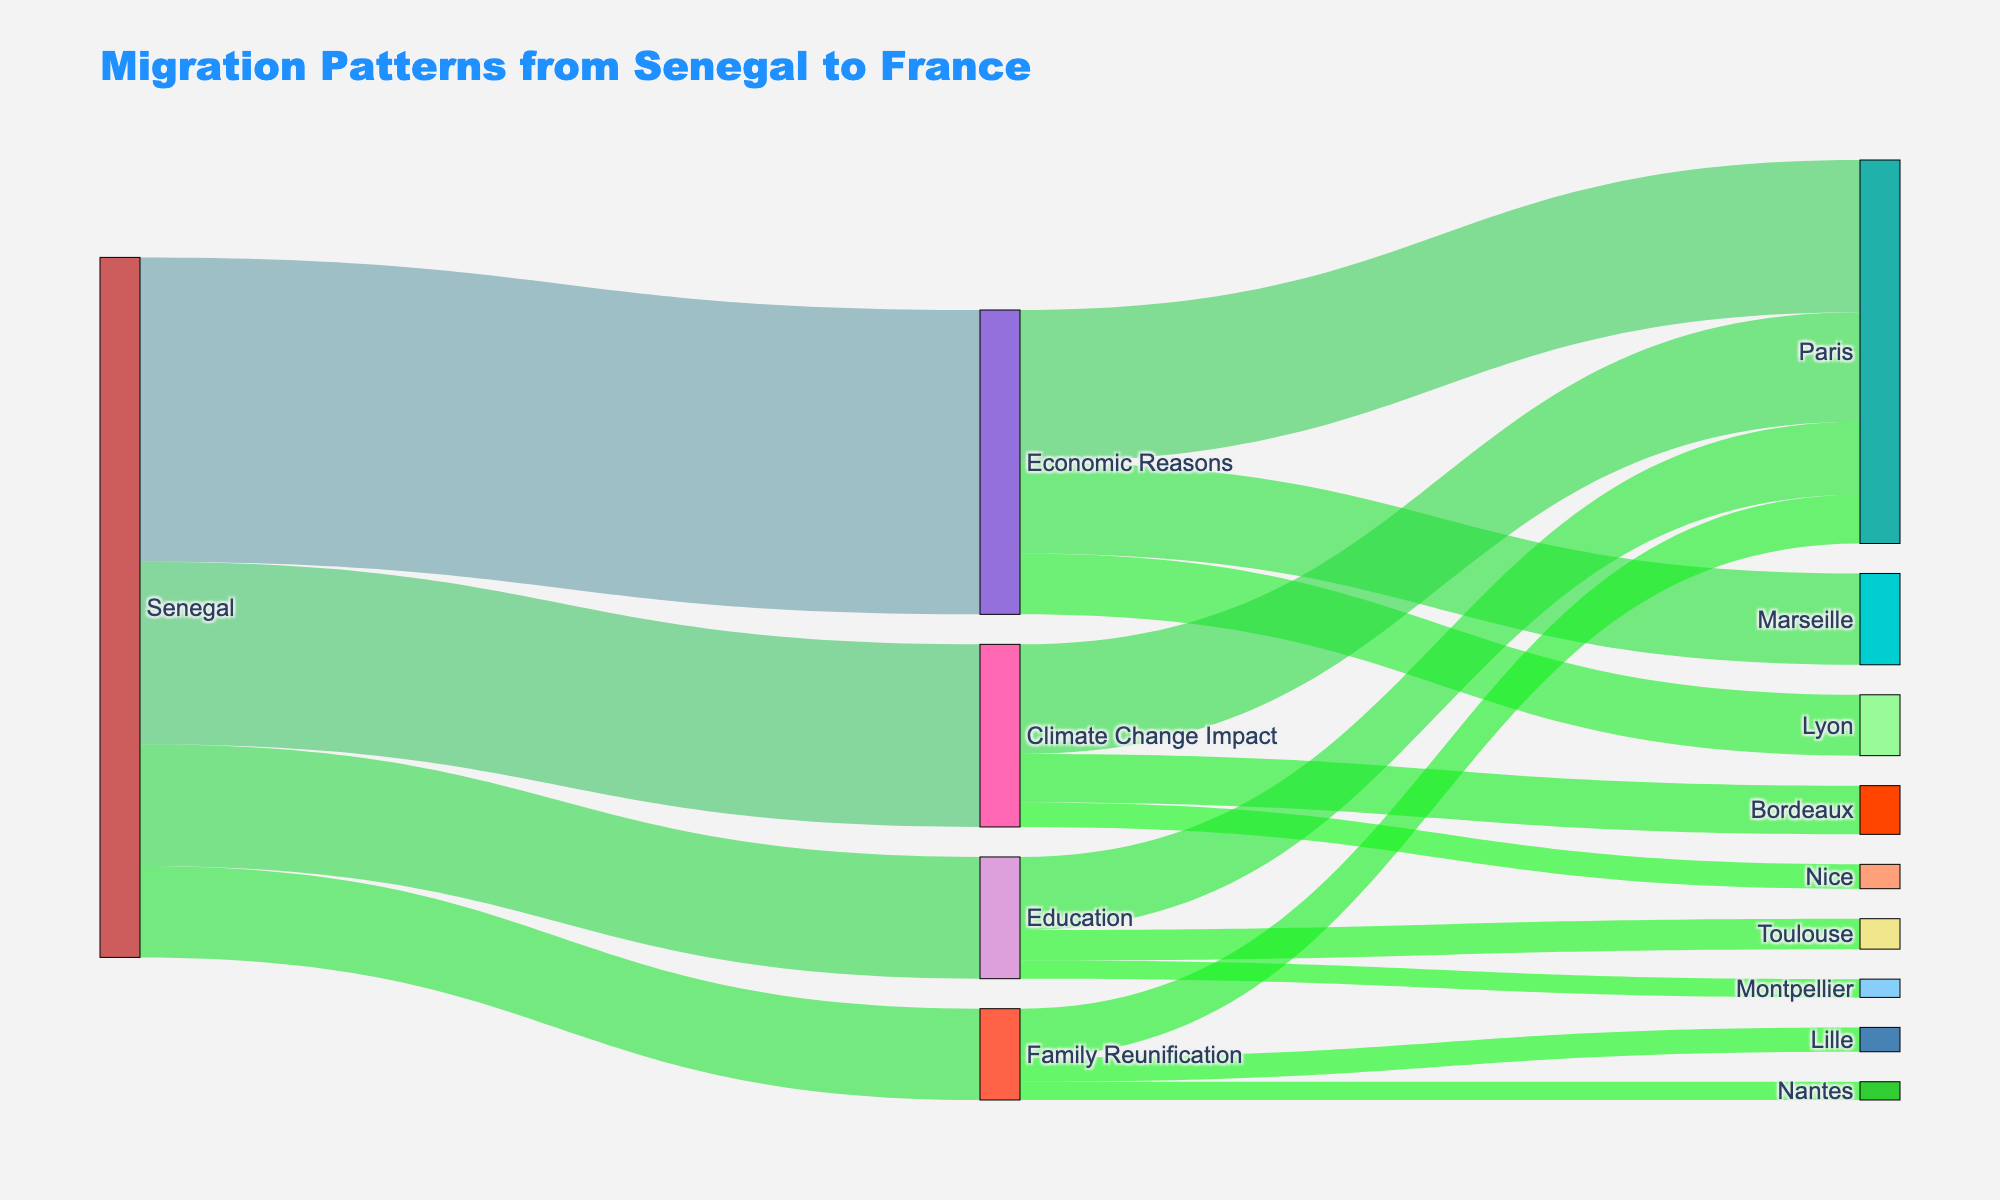What is the title of the Sankey Diagram? The title is displayed at the top of the diagram. Reading it, we see: "Migration Patterns from Senegal to France".
Answer: Migration Patterns from Senegal to France How many people migrated from Senegal for Economic Reasons? You can find this by looking for the flow from Senegal to Economic Reasons. The value attached to this flow is 5000.
Answer: 5000 Which destination city received the highest number of migrants due to Economic Reasons? To answer this, observe the flows from Economic Reasons to different cities. The highest value among these flows is 2500, going to Paris.
Answer: Paris What are the top two reasons for migration from Senegal? Examine the flows originating from Senegal to the reasons. The flows show 5000 for Economic Reasons and 3000 for Climate Change Impact, indicating these are the top two reasons.
Answer: Economic Reasons and Climate Change Impact How many people migrated to Paris for Family Reunification? Locate the flow from Family Reunification to Paris, which shows a value of 800.
Answer: 800 Which migration reason has the lowest number of people, and how many people are associated with it? Look at the values of flows from Senegal to each reason. Education has the lowest value of 2000.
Answer: Education, 2000 How many people in total migrated from Senegal to France for Education purposes? Sum the values of all flows from Education to different cities. 1200 (Paris) + 500 (Toulouse) + 300 (Montpellier) = 2000.
Answer: 2000 Is the number of people migrating due to Climate Change Impact more or less than those migrating for Family Reunification? By how much? Compare the values from Senegal to Climate Change Impact and Family Reunification. Climate Change Impact is 3000, whereas Family Reunification is 1500. The difference is 3000 - 1500 = 1500.
Answer: More, by 1500 Which city has the most diverse reasons for receiving migrants from Senegal and what are those reasons? Look at the target nodes and check how many different reasons link to each city. Paris has the most diverse reasons: Economic Reasons, Climate Change Impact, Education, Family Reunification.
Answer: Paris, reasons: Economic Reasons, Climate Change Impact, Education, Family Reunification 